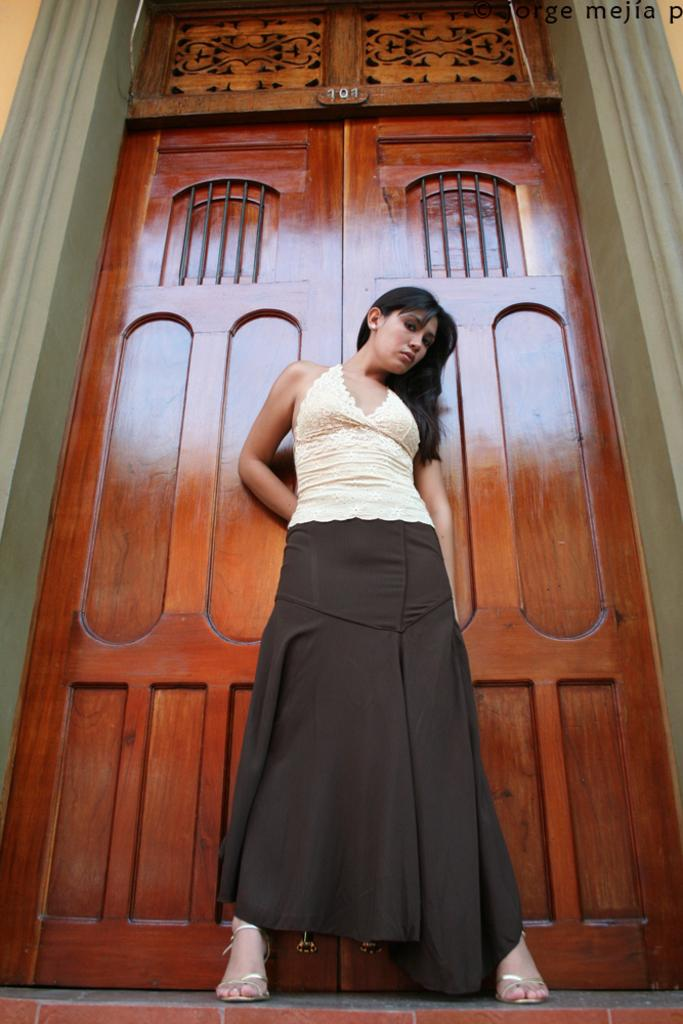What is the main subject of the image? There is a woman standing in the middle of the image. Can you describe the woman's position in the image? The woman is standing in the middle of the image. What is visible in the background of the image? There is a closed door in the background of the image. How many thrones are present in the image? There are no thrones present in the image. What is the starting point for the woman in the image? The image does not indicate a starting point for the woman; it only shows her standing in the middle. 